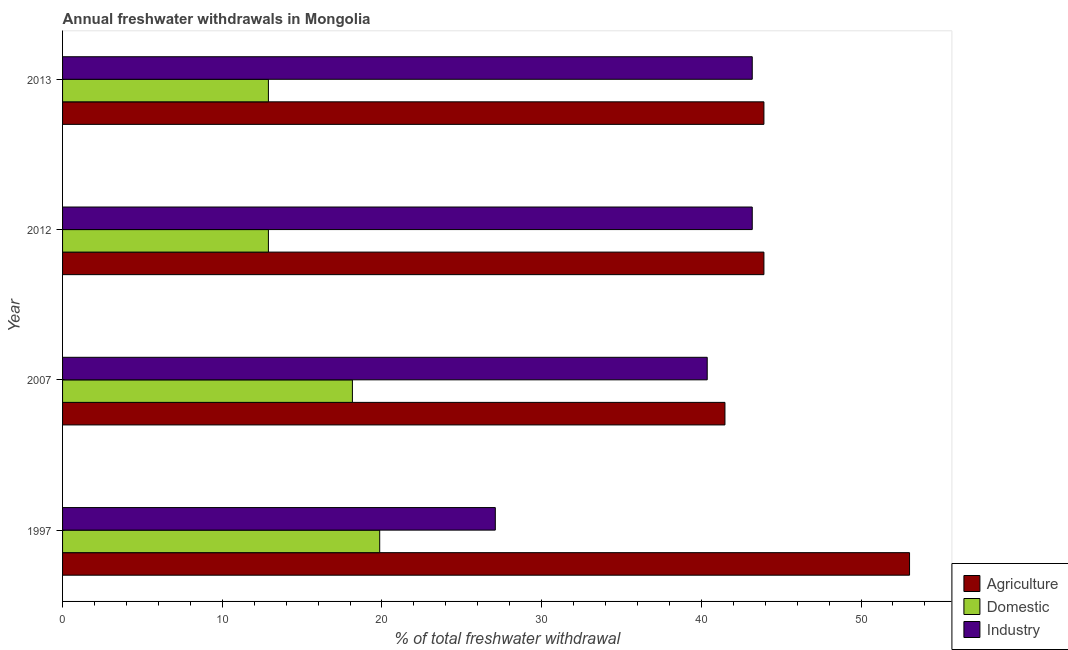How many different coloured bars are there?
Your answer should be very brief. 3. Are the number of bars per tick equal to the number of legend labels?
Give a very brief answer. Yes. Are the number of bars on each tick of the Y-axis equal?
Your response must be concise. Yes. How many bars are there on the 4th tick from the top?
Offer a terse response. 3. What is the label of the 1st group of bars from the top?
Your answer should be compact. 2013. What is the percentage of freshwater withdrawal for agriculture in 2012?
Your answer should be compact. 43.92. Across all years, what is the maximum percentage of freshwater withdrawal for industry?
Provide a succinct answer. 43.19. Across all years, what is the minimum percentage of freshwater withdrawal for industry?
Provide a short and direct response. 27.1. In which year was the percentage of freshwater withdrawal for domestic purposes minimum?
Give a very brief answer. 2012. What is the total percentage of freshwater withdrawal for industry in the graph?
Your response must be concise. 153.85. What is the difference between the percentage of freshwater withdrawal for agriculture in 2007 and that in 2013?
Your answer should be very brief. -2.44. What is the difference between the percentage of freshwater withdrawal for industry in 2007 and the percentage of freshwater withdrawal for agriculture in 2012?
Your response must be concise. -3.55. What is the average percentage of freshwater withdrawal for domestic purposes per year?
Provide a short and direct response. 15.95. In the year 2013, what is the difference between the percentage of freshwater withdrawal for industry and percentage of freshwater withdrawal for domestic purposes?
Your response must be concise. 30.3. What is the ratio of the percentage of freshwater withdrawal for industry in 1997 to that in 2012?
Make the answer very short. 0.63. Is the percentage of freshwater withdrawal for industry in 1997 less than that in 2012?
Make the answer very short. Yes. What is the difference between the highest and the second highest percentage of freshwater withdrawal for agriculture?
Your response must be concise. 9.12. What is the difference between the highest and the lowest percentage of freshwater withdrawal for industry?
Your answer should be compact. 16.09. In how many years, is the percentage of freshwater withdrawal for industry greater than the average percentage of freshwater withdrawal for industry taken over all years?
Your answer should be very brief. 3. Is the sum of the percentage of freshwater withdrawal for industry in 1997 and 2013 greater than the maximum percentage of freshwater withdrawal for agriculture across all years?
Provide a succinct answer. Yes. What does the 1st bar from the top in 2013 represents?
Keep it short and to the point. Industry. What does the 3rd bar from the bottom in 2007 represents?
Make the answer very short. Industry. How many bars are there?
Your answer should be very brief. 12. How many years are there in the graph?
Ensure brevity in your answer.  4. Where does the legend appear in the graph?
Make the answer very short. Bottom right. How many legend labels are there?
Provide a succinct answer. 3. How are the legend labels stacked?
Make the answer very short. Vertical. What is the title of the graph?
Provide a succinct answer. Annual freshwater withdrawals in Mongolia. Does "Manufactures" appear as one of the legend labels in the graph?
Keep it short and to the point. No. What is the label or title of the X-axis?
Give a very brief answer. % of total freshwater withdrawal. What is the % of total freshwater withdrawal of Agriculture in 1997?
Provide a succinct answer. 53.04. What is the % of total freshwater withdrawal of Domestic in 1997?
Your answer should be very brief. 19.86. What is the % of total freshwater withdrawal in Industry in 1997?
Your response must be concise. 27.1. What is the % of total freshwater withdrawal in Agriculture in 2007?
Your response must be concise. 41.48. What is the % of total freshwater withdrawal in Domestic in 2007?
Ensure brevity in your answer.  18.15. What is the % of total freshwater withdrawal of Industry in 2007?
Ensure brevity in your answer.  40.37. What is the % of total freshwater withdrawal in Agriculture in 2012?
Provide a succinct answer. 43.92. What is the % of total freshwater withdrawal of Domestic in 2012?
Your answer should be very brief. 12.89. What is the % of total freshwater withdrawal in Industry in 2012?
Give a very brief answer. 43.19. What is the % of total freshwater withdrawal in Agriculture in 2013?
Ensure brevity in your answer.  43.92. What is the % of total freshwater withdrawal of Domestic in 2013?
Give a very brief answer. 12.89. What is the % of total freshwater withdrawal of Industry in 2013?
Your response must be concise. 43.19. Across all years, what is the maximum % of total freshwater withdrawal of Agriculture?
Your answer should be very brief. 53.04. Across all years, what is the maximum % of total freshwater withdrawal of Domestic?
Make the answer very short. 19.86. Across all years, what is the maximum % of total freshwater withdrawal of Industry?
Make the answer very short. 43.19. Across all years, what is the minimum % of total freshwater withdrawal in Agriculture?
Your answer should be compact. 41.48. Across all years, what is the minimum % of total freshwater withdrawal of Domestic?
Provide a succinct answer. 12.89. Across all years, what is the minimum % of total freshwater withdrawal of Industry?
Your answer should be very brief. 27.1. What is the total % of total freshwater withdrawal of Agriculture in the graph?
Your response must be concise. 182.36. What is the total % of total freshwater withdrawal of Domestic in the graph?
Offer a terse response. 63.79. What is the total % of total freshwater withdrawal of Industry in the graph?
Your answer should be very brief. 153.85. What is the difference between the % of total freshwater withdrawal of Agriculture in 1997 and that in 2007?
Offer a terse response. 11.56. What is the difference between the % of total freshwater withdrawal of Domestic in 1997 and that in 2007?
Give a very brief answer. 1.71. What is the difference between the % of total freshwater withdrawal in Industry in 1997 and that in 2007?
Your answer should be compact. -13.27. What is the difference between the % of total freshwater withdrawal in Agriculture in 1997 and that in 2012?
Provide a succinct answer. 9.12. What is the difference between the % of total freshwater withdrawal in Domestic in 1997 and that in 2012?
Your answer should be very brief. 6.97. What is the difference between the % of total freshwater withdrawal in Industry in 1997 and that in 2012?
Your answer should be very brief. -16.09. What is the difference between the % of total freshwater withdrawal of Agriculture in 1997 and that in 2013?
Provide a succinct answer. 9.12. What is the difference between the % of total freshwater withdrawal in Domestic in 1997 and that in 2013?
Offer a terse response. 6.97. What is the difference between the % of total freshwater withdrawal of Industry in 1997 and that in 2013?
Your response must be concise. -16.09. What is the difference between the % of total freshwater withdrawal of Agriculture in 2007 and that in 2012?
Offer a very short reply. -2.44. What is the difference between the % of total freshwater withdrawal of Domestic in 2007 and that in 2012?
Your response must be concise. 5.26. What is the difference between the % of total freshwater withdrawal in Industry in 2007 and that in 2012?
Your answer should be compact. -2.82. What is the difference between the % of total freshwater withdrawal of Agriculture in 2007 and that in 2013?
Provide a succinct answer. -2.44. What is the difference between the % of total freshwater withdrawal of Domestic in 2007 and that in 2013?
Your response must be concise. 5.26. What is the difference between the % of total freshwater withdrawal in Industry in 2007 and that in 2013?
Give a very brief answer. -2.82. What is the difference between the % of total freshwater withdrawal of Agriculture in 2012 and that in 2013?
Your answer should be compact. 0. What is the difference between the % of total freshwater withdrawal in Domestic in 2012 and that in 2013?
Make the answer very short. 0. What is the difference between the % of total freshwater withdrawal in Industry in 2012 and that in 2013?
Give a very brief answer. 0. What is the difference between the % of total freshwater withdrawal of Agriculture in 1997 and the % of total freshwater withdrawal of Domestic in 2007?
Provide a short and direct response. 34.89. What is the difference between the % of total freshwater withdrawal of Agriculture in 1997 and the % of total freshwater withdrawal of Industry in 2007?
Offer a very short reply. 12.67. What is the difference between the % of total freshwater withdrawal in Domestic in 1997 and the % of total freshwater withdrawal in Industry in 2007?
Provide a short and direct response. -20.51. What is the difference between the % of total freshwater withdrawal of Agriculture in 1997 and the % of total freshwater withdrawal of Domestic in 2012?
Make the answer very short. 40.15. What is the difference between the % of total freshwater withdrawal of Agriculture in 1997 and the % of total freshwater withdrawal of Industry in 2012?
Your answer should be very brief. 9.85. What is the difference between the % of total freshwater withdrawal in Domestic in 1997 and the % of total freshwater withdrawal in Industry in 2012?
Make the answer very short. -23.33. What is the difference between the % of total freshwater withdrawal of Agriculture in 1997 and the % of total freshwater withdrawal of Domestic in 2013?
Provide a short and direct response. 40.15. What is the difference between the % of total freshwater withdrawal of Agriculture in 1997 and the % of total freshwater withdrawal of Industry in 2013?
Keep it short and to the point. 9.85. What is the difference between the % of total freshwater withdrawal in Domestic in 1997 and the % of total freshwater withdrawal in Industry in 2013?
Make the answer very short. -23.33. What is the difference between the % of total freshwater withdrawal of Agriculture in 2007 and the % of total freshwater withdrawal of Domestic in 2012?
Offer a terse response. 28.59. What is the difference between the % of total freshwater withdrawal in Agriculture in 2007 and the % of total freshwater withdrawal in Industry in 2012?
Ensure brevity in your answer.  -1.71. What is the difference between the % of total freshwater withdrawal of Domestic in 2007 and the % of total freshwater withdrawal of Industry in 2012?
Give a very brief answer. -25.04. What is the difference between the % of total freshwater withdrawal of Agriculture in 2007 and the % of total freshwater withdrawal of Domestic in 2013?
Keep it short and to the point. 28.59. What is the difference between the % of total freshwater withdrawal in Agriculture in 2007 and the % of total freshwater withdrawal in Industry in 2013?
Your response must be concise. -1.71. What is the difference between the % of total freshwater withdrawal of Domestic in 2007 and the % of total freshwater withdrawal of Industry in 2013?
Provide a short and direct response. -25.04. What is the difference between the % of total freshwater withdrawal of Agriculture in 2012 and the % of total freshwater withdrawal of Domestic in 2013?
Make the answer very short. 31.03. What is the difference between the % of total freshwater withdrawal of Agriculture in 2012 and the % of total freshwater withdrawal of Industry in 2013?
Provide a short and direct response. 0.73. What is the difference between the % of total freshwater withdrawal of Domestic in 2012 and the % of total freshwater withdrawal of Industry in 2013?
Offer a very short reply. -30.3. What is the average % of total freshwater withdrawal of Agriculture per year?
Your answer should be very brief. 45.59. What is the average % of total freshwater withdrawal of Domestic per year?
Your response must be concise. 15.95. What is the average % of total freshwater withdrawal in Industry per year?
Provide a short and direct response. 38.46. In the year 1997, what is the difference between the % of total freshwater withdrawal of Agriculture and % of total freshwater withdrawal of Domestic?
Provide a short and direct response. 33.18. In the year 1997, what is the difference between the % of total freshwater withdrawal in Agriculture and % of total freshwater withdrawal in Industry?
Your answer should be compact. 25.94. In the year 1997, what is the difference between the % of total freshwater withdrawal of Domestic and % of total freshwater withdrawal of Industry?
Provide a succinct answer. -7.24. In the year 2007, what is the difference between the % of total freshwater withdrawal in Agriculture and % of total freshwater withdrawal in Domestic?
Make the answer very short. 23.33. In the year 2007, what is the difference between the % of total freshwater withdrawal of Agriculture and % of total freshwater withdrawal of Industry?
Your response must be concise. 1.11. In the year 2007, what is the difference between the % of total freshwater withdrawal of Domestic and % of total freshwater withdrawal of Industry?
Offer a very short reply. -22.22. In the year 2012, what is the difference between the % of total freshwater withdrawal in Agriculture and % of total freshwater withdrawal in Domestic?
Your response must be concise. 31.03. In the year 2012, what is the difference between the % of total freshwater withdrawal in Agriculture and % of total freshwater withdrawal in Industry?
Ensure brevity in your answer.  0.73. In the year 2012, what is the difference between the % of total freshwater withdrawal of Domestic and % of total freshwater withdrawal of Industry?
Provide a short and direct response. -30.3. In the year 2013, what is the difference between the % of total freshwater withdrawal in Agriculture and % of total freshwater withdrawal in Domestic?
Make the answer very short. 31.03. In the year 2013, what is the difference between the % of total freshwater withdrawal of Agriculture and % of total freshwater withdrawal of Industry?
Offer a very short reply. 0.73. In the year 2013, what is the difference between the % of total freshwater withdrawal of Domestic and % of total freshwater withdrawal of Industry?
Give a very brief answer. -30.3. What is the ratio of the % of total freshwater withdrawal in Agriculture in 1997 to that in 2007?
Provide a short and direct response. 1.28. What is the ratio of the % of total freshwater withdrawal in Domestic in 1997 to that in 2007?
Your response must be concise. 1.09. What is the ratio of the % of total freshwater withdrawal in Industry in 1997 to that in 2007?
Your answer should be very brief. 0.67. What is the ratio of the % of total freshwater withdrawal of Agriculture in 1997 to that in 2012?
Your answer should be very brief. 1.21. What is the ratio of the % of total freshwater withdrawal in Domestic in 1997 to that in 2012?
Ensure brevity in your answer.  1.54. What is the ratio of the % of total freshwater withdrawal in Industry in 1997 to that in 2012?
Make the answer very short. 0.63. What is the ratio of the % of total freshwater withdrawal in Agriculture in 1997 to that in 2013?
Make the answer very short. 1.21. What is the ratio of the % of total freshwater withdrawal of Domestic in 1997 to that in 2013?
Provide a short and direct response. 1.54. What is the ratio of the % of total freshwater withdrawal of Industry in 1997 to that in 2013?
Your response must be concise. 0.63. What is the ratio of the % of total freshwater withdrawal in Agriculture in 2007 to that in 2012?
Provide a short and direct response. 0.94. What is the ratio of the % of total freshwater withdrawal of Domestic in 2007 to that in 2012?
Provide a short and direct response. 1.41. What is the ratio of the % of total freshwater withdrawal in Industry in 2007 to that in 2012?
Keep it short and to the point. 0.93. What is the ratio of the % of total freshwater withdrawal of Domestic in 2007 to that in 2013?
Offer a terse response. 1.41. What is the ratio of the % of total freshwater withdrawal in Industry in 2007 to that in 2013?
Provide a succinct answer. 0.93. What is the ratio of the % of total freshwater withdrawal in Domestic in 2012 to that in 2013?
Keep it short and to the point. 1. What is the difference between the highest and the second highest % of total freshwater withdrawal of Agriculture?
Your response must be concise. 9.12. What is the difference between the highest and the second highest % of total freshwater withdrawal in Domestic?
Make the answer very short. 1.71. What is the difference between the highest and the second highest % of total freshwater withdrawal of Industry?
Your response must be concise. 0. What is the difference between the highest and the lowest % of total freshwater withdrawal in Agriculture?
Offer a terse response. 11.56. What is the difference between the highest and the lowest % of total freshwater withdrawal of Domestic?
Give a very brief answer. 6.97. What is the difference between the highest and the lowest % of total freshwater withdrawal of Industry?
Keep it short and to the point. 16.09. 